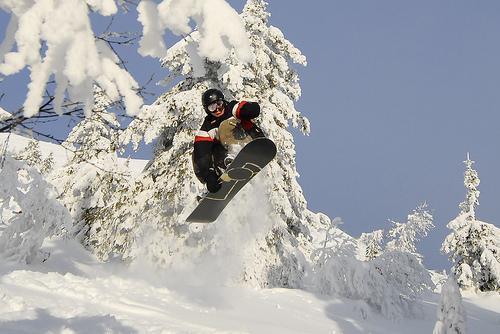How many people are in the photo?
Give a very brief answer. 1. 